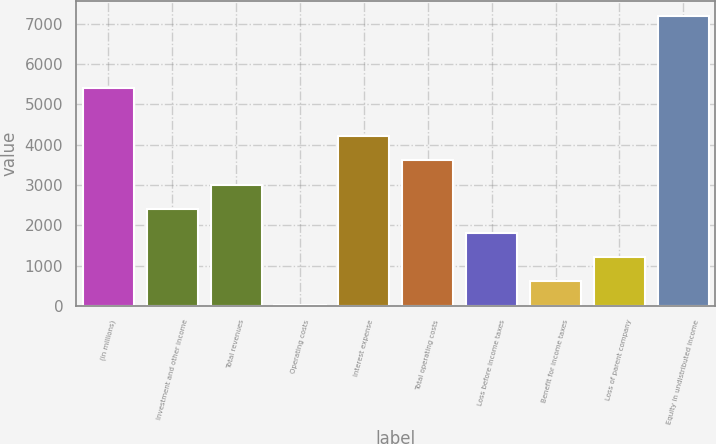Convert chart to OTSL. <chart><loc_0><loc_0><loc_500><loc_500><bar_chart><fcel>(in millions)<fcel>Investment and other income<fcel>Total revenues<fcel>Operating costs<fcel>Interest expense<fcel>Total operating costs<fcel>Loss before income taxes<fcel>Benefit for income taxes<fcel>Loss of parent company<fcel>Equity in undistributed income<nl><fcel>5407.1<fcel>2412.6<fcel>3011.5<fcel>17<fcel>4209.3<fcel>3610.4<fcel>1813.7<fcel>615.9<fcel>1214.8<fcel>7203.8<nl></chart> 